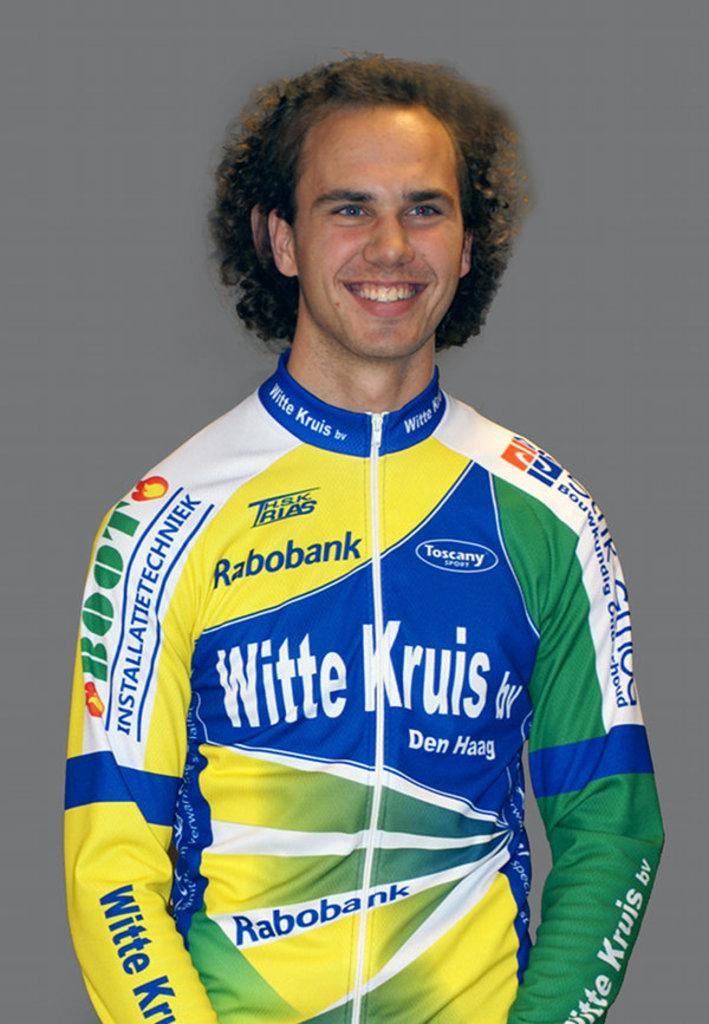<image>
Give a short and clear explanation of the subsequent image. A man is wearing a jacket with multiple sponsors, including Toscany Sport and Rabobank. 